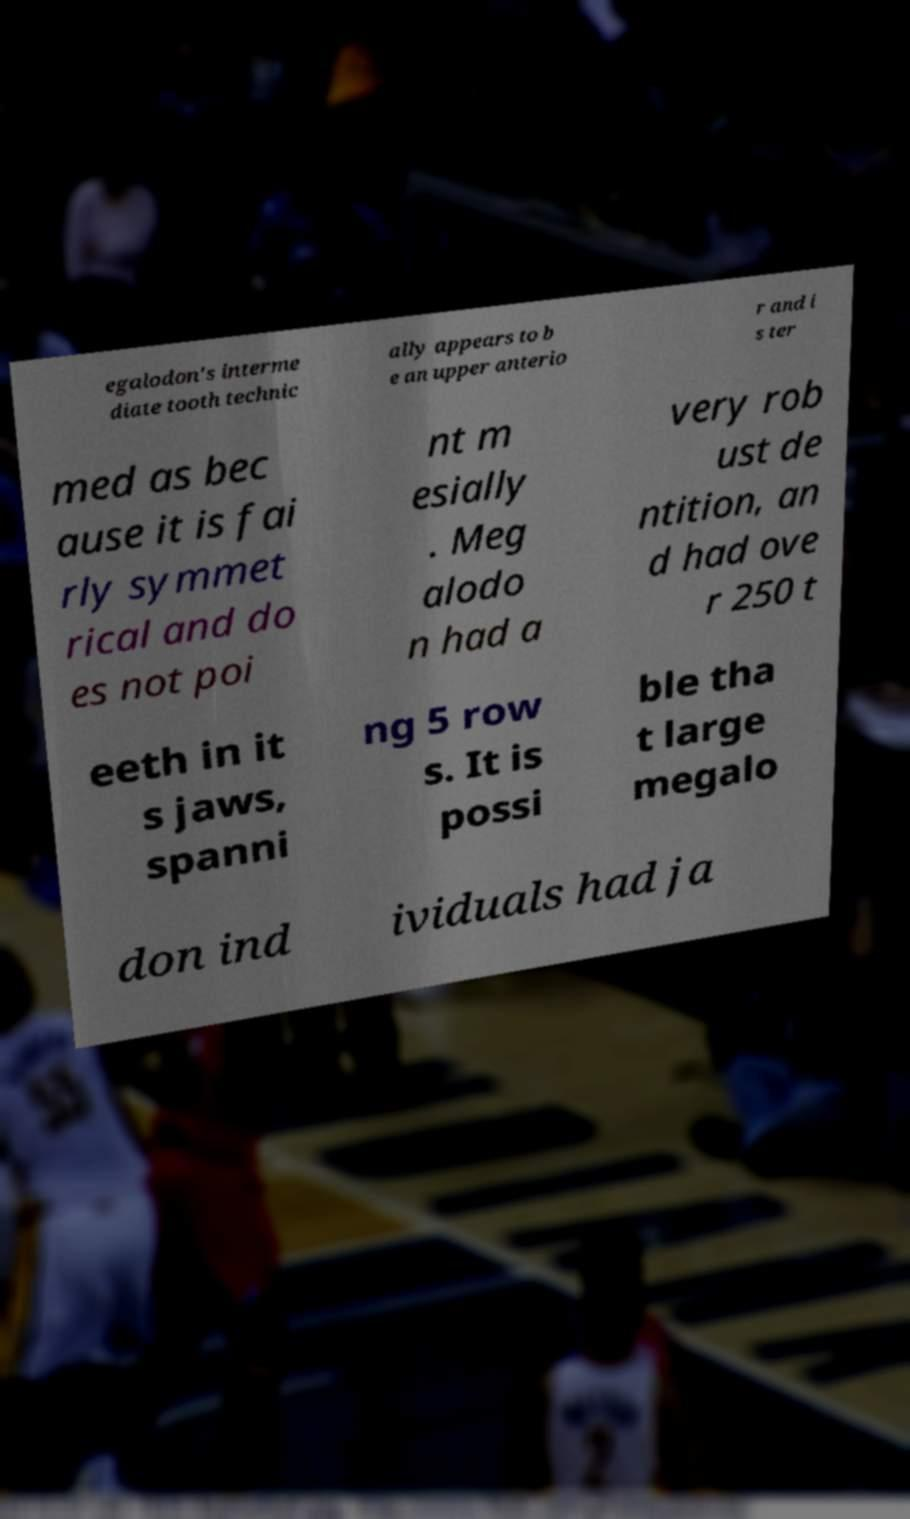I need the written content from this picture converted into text. Can you do that? egalodon's interme diate tooth technic ally appears to b e an upper anterio r and i s ter med as bec ause it is fai rly symmet rical and do es not poi nt m esially . Meg alodo n had a very rob ust de ntition, an d had ove r 250 t eeth in it s jaws, spanni ng 5 row s. It is possi ble tha t large megalo don ind ividuals had ja 